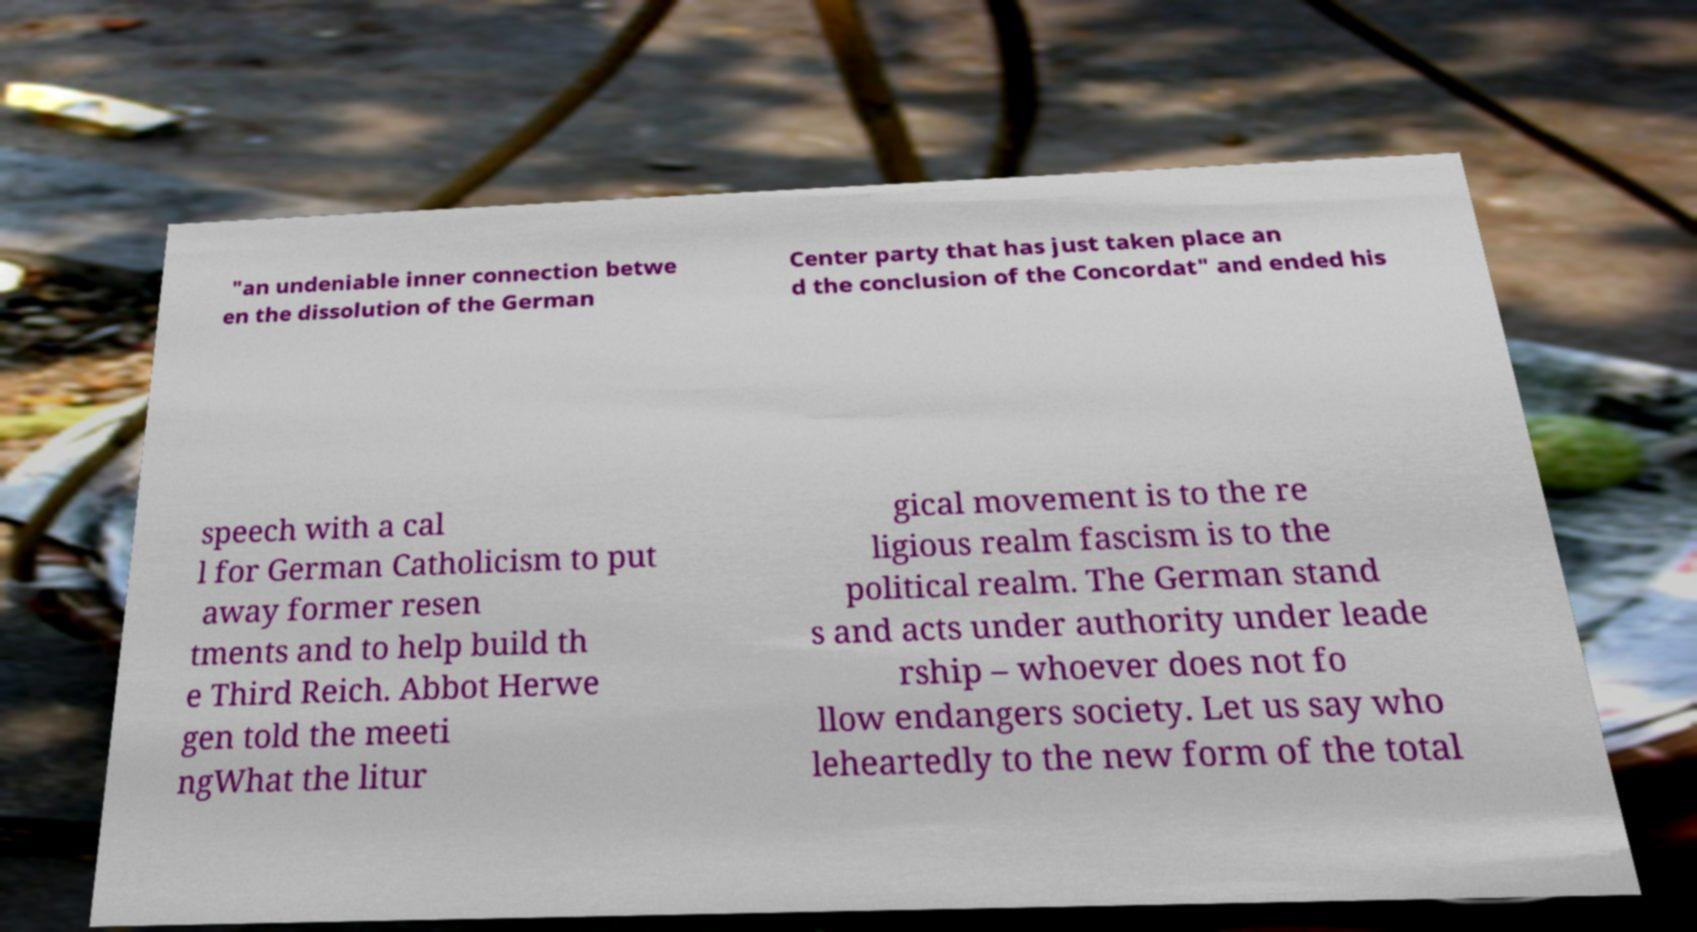What messages or text are displayed in this image? I need them in a readable, typed format. "an undeniable inner connection betwe en the dissolution of the German Center party that has just taken place an d the conclusion of the Concordat" and ended his speech with a cal l for German Catholicism to put away former resen tments and to help build th e Third Reich. Abbot Herwe gen told the meeti ngWhat the litur gical movement is to the re ligious realm fascism is to the political realm. The German stand s and acts under authority under leade rship – whoever does not fo llow endangers society. Let us say who leheartedly to the new form of the total 